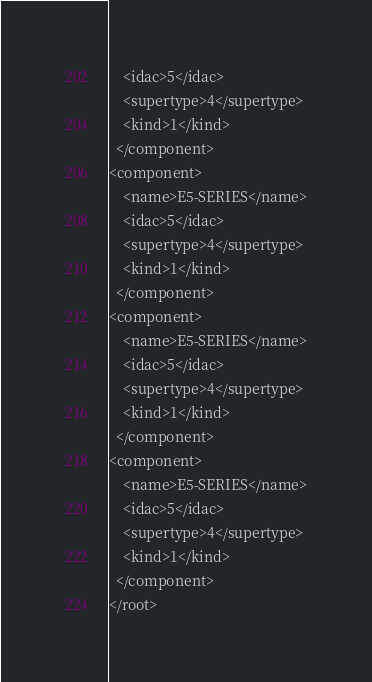Convert code to text. <code><loc_0><loc_0><loc_500><loc_500><_XML_>    <idac>5</idac>
    <supertype>4</supertype>
    <kind>1</kind>
  </component>
<component>
    <name>E5-SERIES</name>
    <idac>5</idac>
    <supertype>4</supertype>
    <kind>1</kind>
  </component>
<component>
    <name>E5-SERIES</name>
    <idac>5</idac>
    <supertype>4</supertype>
    <kind>1</kind>
  </component>
<component>
    <name>E5-SERIES</name>
    <idac>5</idac>
    <supertype>4</supertype>
    <kind>1</kind>
  </component>
</root>
</code> 